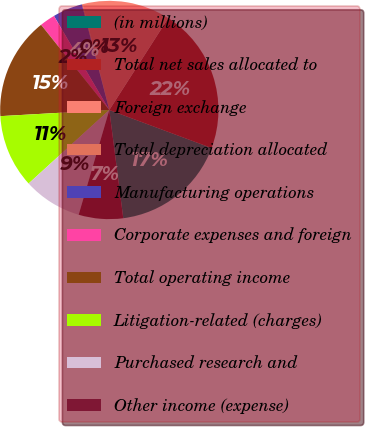Convert chart to OTSL. <chart><loc_0><loc_0><loc_500><loc_500><pie_chart><fcel>(in millions)<fcel>Total net sales allocated to<fcel>Foreign exchange<fcel>Total depreciation allocated<fcel>Manufacturing operations<fcel>Corporate expenses and foreign<fcel>Total operating income<fcel>Litigation-related (charges)<fcel>Purchased research and<fcel>Other income (expense)<nl><fcel>17.29%<fcel>21.58%<fcel>13.0%<fcel>0.13%<fcel>4.42%<fcel>2.28%<fcel>15.15%<fcel>10.86%<fcel>8.71%<fcel>6.57%<nl></chart> 